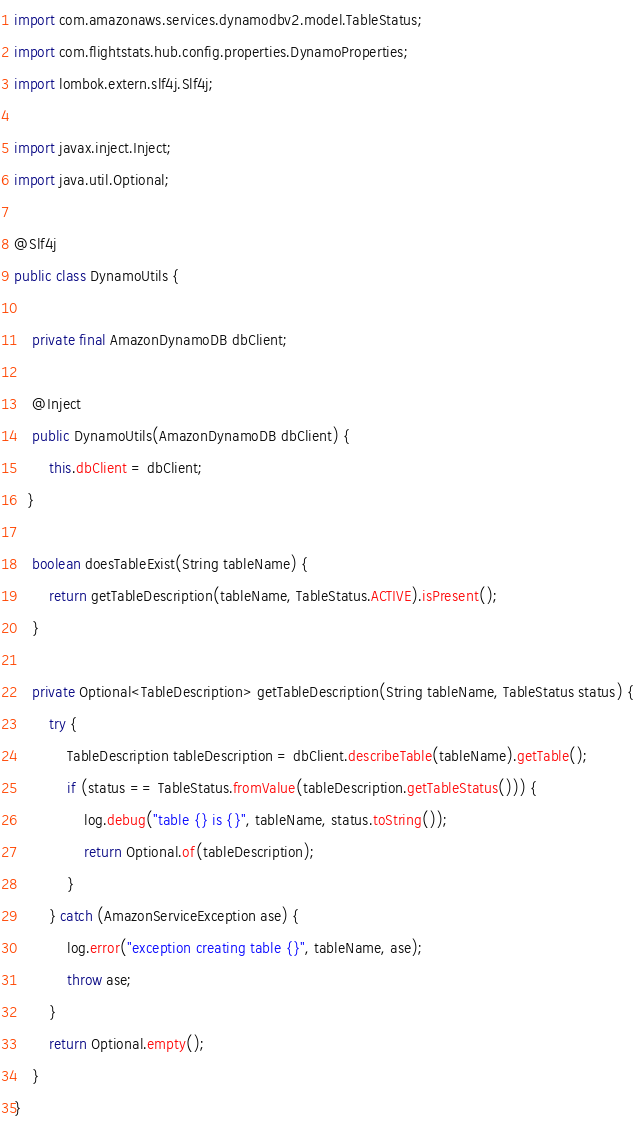<code> <loc_0><loc_0><loc_500><loc_500><_Java_>import com.amazonaws.services.dynamodbv2.model.TableStatus;
import com.flightstats.hub.config.properties.DynamoProperties;
import lombok.extern.slf4j.Slf4j;

import javax.inject.Inject;
import java.util.Optional;

@Slf4j
public class DynamoUtils {

    private final AmazonDynamoDB dbClient;

    @Inject
    public DynamoUtils(AmazonDynamoDB dbClient) {
        this.dbClient = dbClient;
   }

    boolean doesTableExist(String tableName) {
        return getTableDescription(tableName, TableStatus.ACTIVE).isPresent();
    }

    private Optional<TableDescription> getTableDescription(String tableName, TableStatus status) {
        try {
            TableDescription tableDescription = dbClient.describeTable(tableName).getTable();
            if (status == TableStatus.fromValue(tableDescription.getTableStatus())) {
                log.debug("table {} is {}", tableName, status.toString());
                return Optional.of(tableDescription);
            }
        } catch (AmazonServiceException ase) {
            log.error("exception creating table {}", tableName, ase);
            throw ase;
        }
        return Optional.empty();
    }
}
</code> 